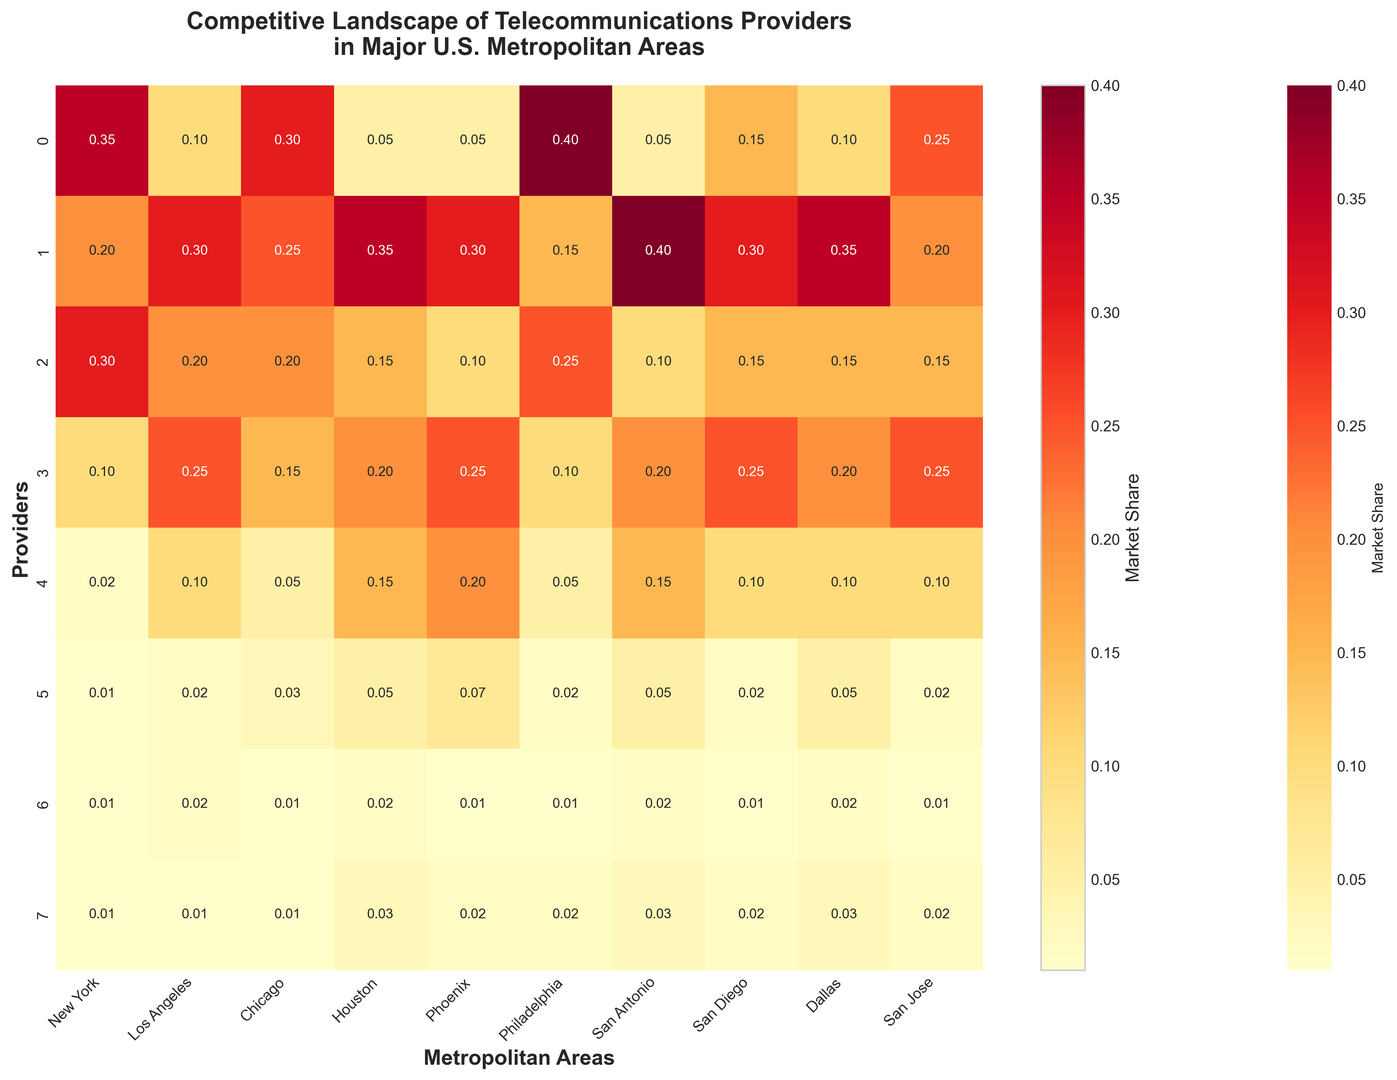Which provider has the highest market share in Philadelphia? Look at the Philadelphia column and find the largest value; it belongs to Comcast with a share of 0.40.
Answer: Comcast What is the combined market share of AT&T and Verizon in San Antonio? Add the market shares of AT&T and Verizon in San Antonio: 0.40 (AT&T) + 0.10 (Verizon) = 0.50.
Answer: 0.50 How does Comcast's market share in New York compare to its market share in Los Angeles? Compare the values in the New York (0.35) and Los Angeles (0.10) columns for Comcast. Comcast has a higher market share in New York than in Los Angeles.
Answer: Higher in New York Which metropolitan area shows the lowest market share for CenturyLink? Look through the CenturyLink row to find the smallest value, which is 0.01 in New York, Los Angeles, San Diego, Philadelphia, and San Jose.
Answer: New York, Los Angeles, San Diego, Philadelphia, San Jose What is the average market share of Charter Spectrum across all listed metropolitan areas? Add Charter Spectrum's market shares across all metropolitan areas (0.10+0.25+0.15+0.20+0.25+0.10+0.20+0.25+0.20+0.25) and divide by the number of areas (10): sum is 1.95, so average is 1.95 / 10 = 0.195.
Answer: 0.195 Which provider has the smallest market share in Phoenix and what is the value? Scan the Phoenix column to find the smallest value; it belongs to Frontier with a share of 0.01.
Answer: Frontier, 0.01 Determine the total market share of all providers in Houston. Sum all values in the Houston column: 0.05 (Comcast) + 0.35 (AT&T) + 0.15 (Verizon) + 0.20 (Charter Spectrum) + 0.15 (Cox Communications) + 0.05 (CenturyLink) + 0.02 (Frontier) + 0.03 (RCN) = 1.00.
Answer: 1.00 What is the difference in market share between Comcast and AT&T in Dallas? Subtract AT&T's market share from Comcast's in Dallas: 0.10 (Comcast) - 0.35 (AT&T) = -0.25.
Answer: -0.25 Which metropolitan area has the highest total market share for Verizon? Look at the Verizon row and find the largest value, which is 0.30 in New York.
Answer: New York What is the visual difference between the market shares of Comcast and Cox Communications in San Diego? The color intensity indicates higher values; Comcast's share is 0.15 (darker color) while Cox Communications' is 0.10 (lighter color).
Answer: Comcast has a darker color 